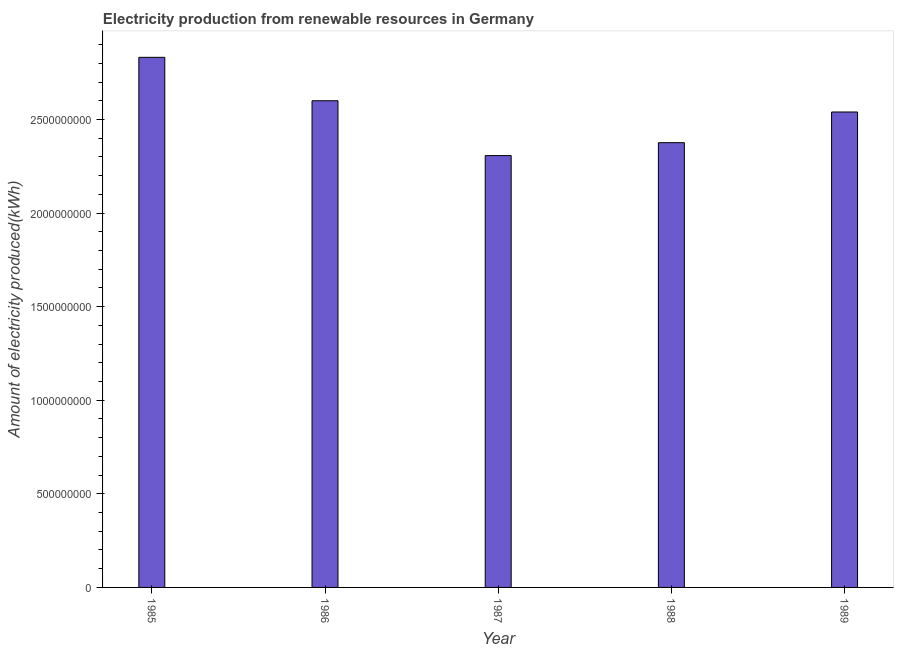What is the title of the graph?
Your response must be concise. Electricity production from renewable resources in Germany. What is the label or title of the X-axis?
Keep it short and to the point. Year. What is the label or title of the Y-axis?
Offer a very short reply. Amount of electricity produced(kWh). What is the amount of electricity produced in 1988?
Keep it short and to the point. 2.38e+09. Across all years, what is the maximum amount of electricity produced?
Your answer should be compact. 2.83e+09. Across all years, what is the minimum amount of electricity produced?
Provide a succinct answer. 2.31e+09. In which year was the amount of electricity produced maximum?
Keep it short and to the point. 1985. In which year was the amount of electricity produced minimum?
Provide a short and direct response. 1987. What is the sum of the amount of electricity produced?
Offer a terse response. 1.27e+1. What is the difference between the amount of electricity produced in 1986 and 1989?
Make the answer very short. 6.00e+07. What is the average amount of electricity produced per year?
Your response must be concise. 2.53e+09. What is the median amount of electricity produced?
Offer a terse response. 2.54e+09. In how many years, is the amount of electricity produced greater than 1600000000 kWh?
Your answer should be very brief. 5. Do a majority of the years between 1985 and 1989 (inclusive) have amount of electricity produced greater than 1900000000 kWh?
Offer a terse response. Yes. What is the ratio of the amount of electricity produced in 1987 to that in 1989?
Offer a terse response. 0.91. Is the difference between the amount of electricity produced in 1988 and 1989 greater than the difference between any two years?
Your answer should be very brief. No. What is the difference between the highest and the second highest amount of electricity produced?
Provide a succinct answer. 2.32e+08. What is the difference between the highest and the lowest amount of electricity produced?
Make the answer very short. 5.25e+08. In how many years, is the amount of electricity produced greater than the average amount of electricity produced taken over all years?
Offer a very short reply. 3. How many bars are there?
Offer a very short reply. 5. Are all the bars in the graph horizontal?
Give a very brief answer. No. Are the values on the major ticks of Y-axis written in scientific E-notation?
Offer a very short reply. No. What is the Amount of electricity produced(kWh) in 1985?
Provide a succinct answer. 2.83e+09. What is the Amount of electricity produced(kWh) in 1986?
Make the answer very short. 2.60e+09. What is the Amount of electricity produced(kWh) in 1987?
Keep it short and to the point. 2.31e+09. What is the Amount of electricity produced(kWh) in 1988?
Your response must be concise. 2.38e+09. What is the Amount of electricity produced(kWh) in 1989?
Your answer should be compact. 2.54e+09. What is the difference between the Amount of electricity produced(kWh) in 1985 and 1986?
Make the answer very short. 2.32e+08. What is the difference between the Amount of electricity produced(kWh) in 1985 and 1987?
Offer a terse response. 5.25e+08. What is the difference between the Amount of electricity produced(kWh) in 1985 and 1988?
Provide a short and direct response. 4.56e+08. What is the difference between the Amount of electricity produced(kWh) in 1985 and 1989?
Make the answer very short. 2.92e+08. What is the difference between the Amount of electricity produced(kWh) in 1986 and 1987?
Provide a succinct answer. 2.93e+08. What is the difference between the Amount of electricity produced(kWh) in 1986 and 1988?
Offer a very short reply. 2.24e+08. What is the difference between the Amount of electricity produced(kWh) in 1986 and 1989?
Keep it short and to the point. 6.00e+07. What is the difference between the Amount of electricity produced(kWh) in 1987 and 1988?
Offer a terse response. -6.90e+07. What is the difference between the Amount of electricity produced(kWh) in 1987 and 1989?
Ensure brevity in your answer.  -2.33e+08. What is the difference between the Amount of electricity produced(kWh) in 1988 and 1989?
Offer a very short reply. -1.64e+08. What is the ratio of the Amount of electricity produced(kWh) in 1985 to that in 1986?
Make the answer very short. 1.09. What is the ratio of the Amount of electricity produced(kWh) in 1985 to that in 1987?
Give a very brief answer. 1.23. What is the ratio of the Amount of electricity produced(kWh) in 1985 to that in 1988?
Keep it short and to the point. 1.19. What is the ratio of the Amount of electricity produced(kWh) in 1985 to that in 1989?
Your answer should be very brief. 1.11. What is the ratio of the Amount of electricity produced(kWh) in 1986 to that in 1987?
Keep it short and to the point. 1.13. What is the ratio of the Amount of electricity produced(kWh) in 1986 to that in 1988?
Keep it short and to the point. 1.09. What is the ratio of the Amount of electricity produced(kWh) in 1987 to that in 1989?
Ensure brevity in your answer.  0.91. What is the ratio of the Amount of electricity produced(kWh) in 1988 to that in 1989?
Keep it short and to the point. 0.94. 